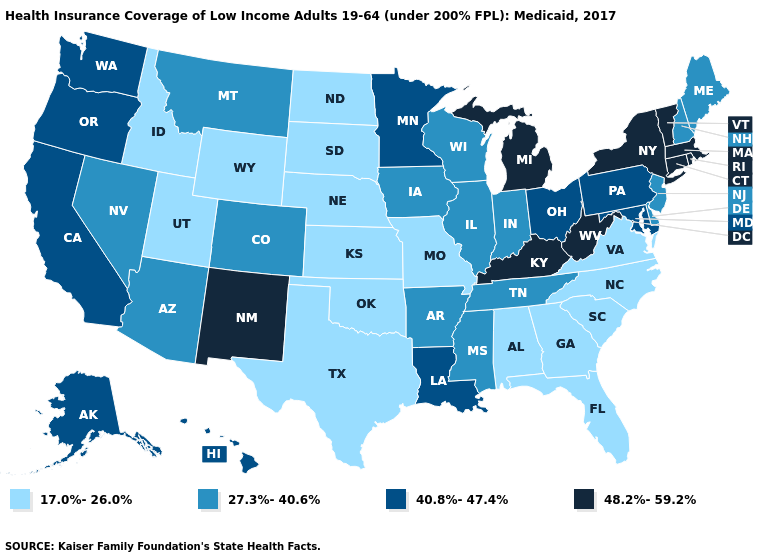Name the states that have a value in the range 27.3%-40.6%?
Short answer required. Arizona, Arkansas, Colorado, Delaware, Illinois, Indiana, Iowa, Maine, Mississippi, Montana, Nevada, New Hampshire, New Jersey, Tennessee, Wisconsin. Which states have the lowest value in the MidWest?
Give a very brief answer. Kansas, Missouri, Nebraska, North Dakota, South Dakota. What is the value of Hawaii?
Short answer required. 40.8%-47.4%. What is the highest value in states that border Tennessee?
Write a very short answer. 48.2%-59.2%. What is the value of Rhode Island?
Quick response, please. 48.2%-59.2%. Does the first symbol in the legend represent the smallest category?
Keep it brief. Yes. What is the value of Georgia?
Write a very short answer. 17.0%-26.0%. Does the first symbol in the legend represent the smallest category?
Short answer required. Yes. What is the highest value in the South ?
Answer briefly. 48.2%-59.2%. Which states hav the highest value in the South?
Write a very short answer. Kentucky, West Virginia. Name the states that have a value in the range 27.3%-40.6%?
Keep it brief. Arizona, Arkansas, Colorado, Delaware, Illinois, Indiana, Iowa, Maine, Mississippi, Montana, Nevada, New Hampshire, New Jersey, Tennessee, Wisconsin. Name the states that have a value in the range 27.3%-40.6%?
Concise answer only. Arizona, Arkansas, Colorado, Delaware, Illinois, Indiana, Iowa, Maine, Mississippi, Montana, Nevada, New Hampshire, New Jersey, Tennessee, Wisconsin. What is the lowest value in the South?
Write a very short answer. 17.0%-26.0%. What is the value of Florida?
Give a very brief answer. 17.0%-26.0%. What is the highest value in states that border Tennessee?
Short answer required. 48.2%-59.2%. 